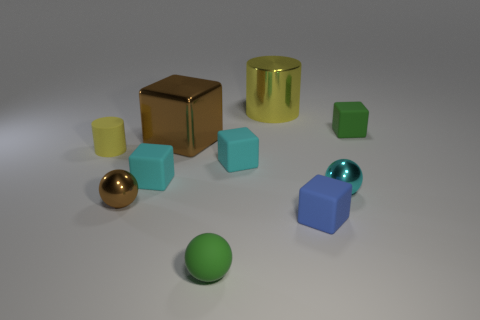Is the size of the green matte ball the same as the metallic sphere to the right of the blue matte cube?
Provide a short and direct response. Yes. There is a large metal object that is the same shape as the small blue thing; what is its color?
Make the answer very short. Brown. There is a sphere to the right of the tiny blue block; is it the same size as the yellow thing that is in front of the small green rubber block?
Your response must be concise. Yes. Does the large yellow shiny thing have the same shape as the yellow rubber thing?
Provide a succinct answer. Yes. What number of things are either brown things in front of the cyan shiny thing or brown cubes?
Offer a terse response. 2. Is there a tiny brown metallic object that has the same shape as the cyan shiny thing?
Offer a very short reply. Yes. Is the number of small green matte objects that are to the left of the yellow metallic cylinder the same as the number of tiny yellow rubber cylinders?
Keep it short and to the point. Yes. The small thing that is the same color as the large cylinder is what shape?
Keep it short and to the point. Cylinder. What number of yellow rubber cylinders have the same size as the brown shiny sphere?
Provide a succinct answer. 1. What number of large yellow things are in front of the small green ball?
Make the answer very short. 0. 